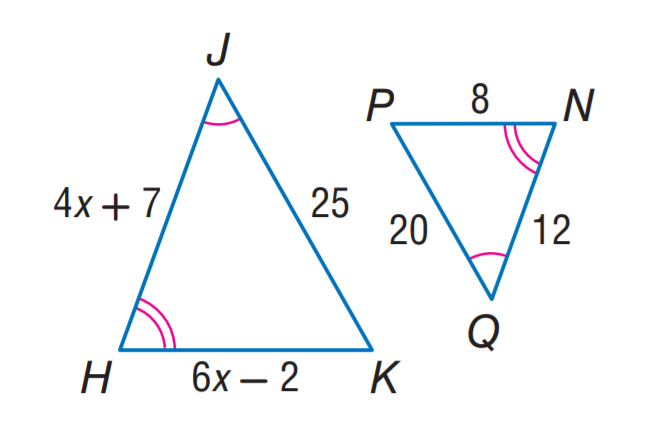Answer the mathemtical geometry problem and directly provide the correct option letter.
Question: Find H K.
Choices: A: 10 B: 12 C: 15 D: 20 A 